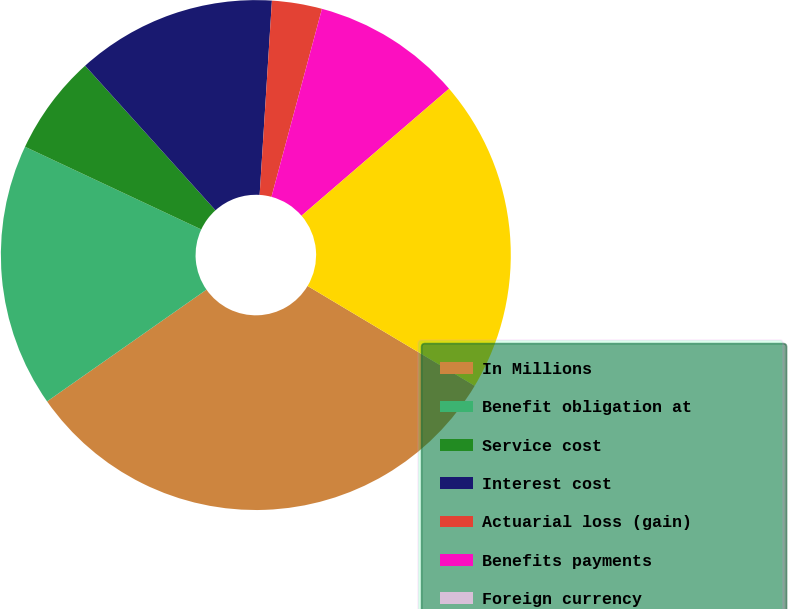Convert chart to OTSL. <chart><loc_0><loc_0><loc_500><loc_500><pie_chart><fcel>In Millions<fcel>Benefit obligation at<fcel>Service cost<fcel>Interest cost<fcel>Actuarial loss (gain)<fcel>Benefits payments<fcel>Foreign currency<fcel>Projected benefit obligation<nl><fcel>31.69%<fcel>16.71%<fcel>6.34%<fcel>12.68%<fcel>3.17%<fcel>9.51%<fcel>0.0%<fcel>19.88%<nl></chart> 